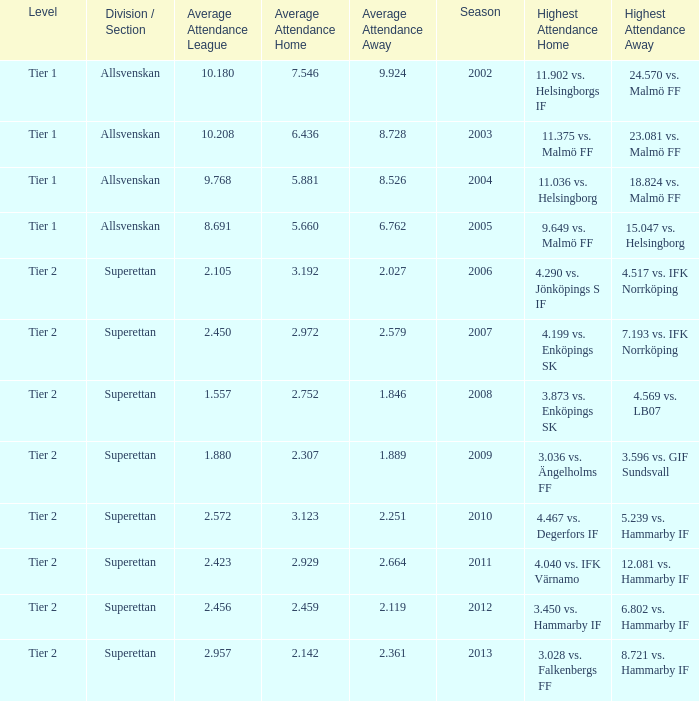How many season have an average attendance league of 2.456? 2012.0. 